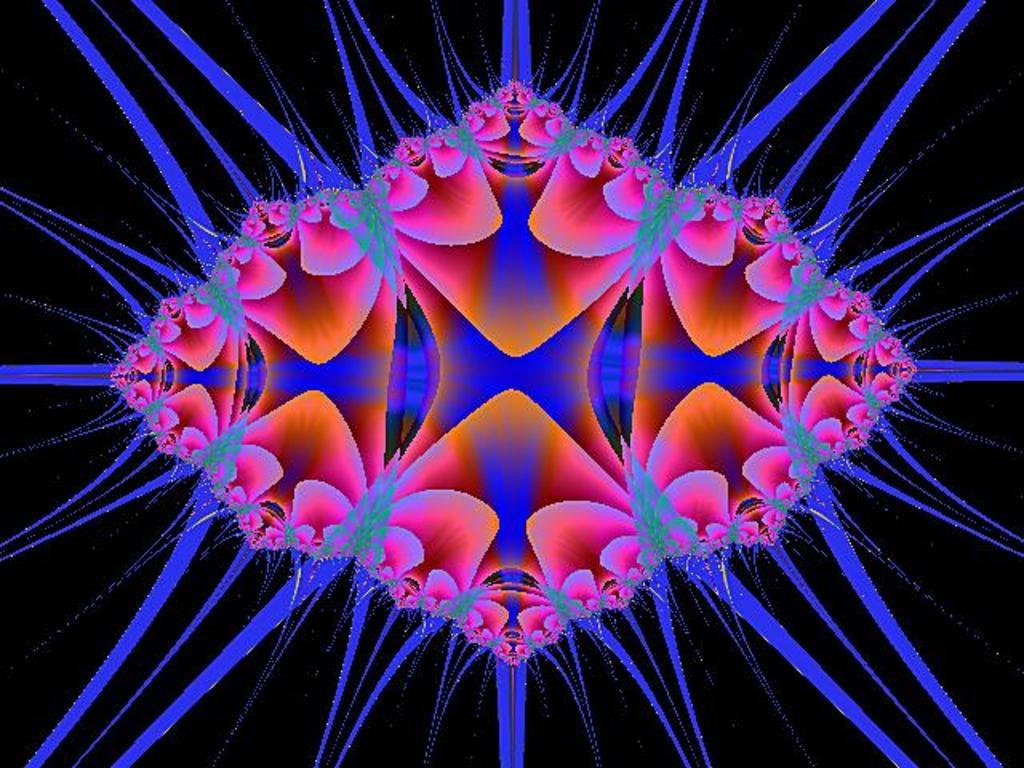What type of winter suit is being worn by the paste in the image? There is no image, paste, or winter suit present in this scenario, as there are no facts provided about the image. 